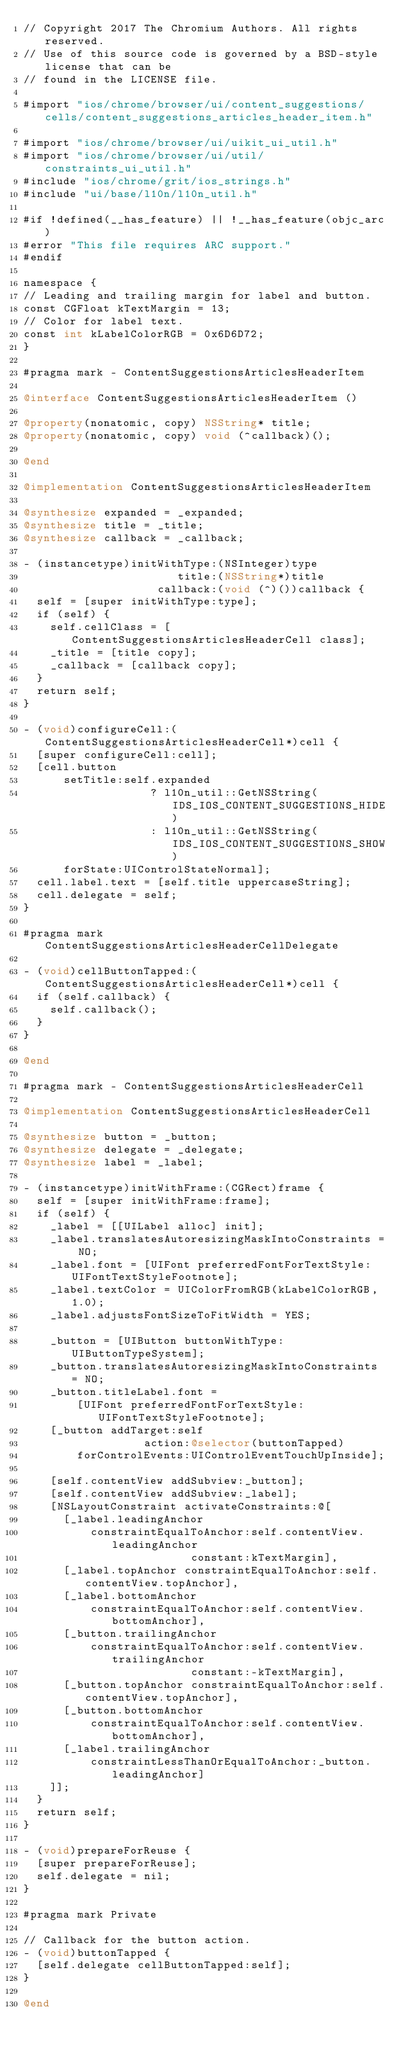Convert code to text. <code><loc_0><loc_0><loc_500><loc_500><_ObjectiveC_>// Copyright 2017 The Chromium Authors. All rights reserved.
// Use of this source code is governed by a BSD-style license that can be
// found in the LICENSE file.

#import "ios/chrome/browser/ui/content_suggestions/cells/content_suggestions_articles_header_item.h"

#import "ios/chrome/browser/ui/uikit_ui_util.h"
#import "ios/chrome/browser/ui/util/constraints_ui_util.h"
#include "ios/chrome/grit/ios_strings.h"
#include "ui/base/l10n/l10n_util.h"

#if !defined(__has_feature) || !__has_feature(objc_arc)
#error "This file requires ARC support."
#endif

namespace {
// Leading and trailing margin for label and button.
const CGFloat kTextMargin = 13;
// Color for label text.
const int kLabelColorRGB = 0x6D6D72;
}

#pragma mark - ContentSuggestionsArticlesHeaderItem

@interface ContentSuggestionsArticlesHeaderItem ()

@property(nonatomic, copy) NSString* title;
@property(nonatomic, copy) void (^callback)();

@end

@implementation ContentSuggestionsArticlesHeaderItem

@synthesize expanded = _expanded;
@synthesize title = _title;
@synthesize callback = _callback;

- (instancetype)initWithType:(NSInteger)type
                       title:(NSString*)title
                    callback:(void (^)())callback {
  self = [super initWithType:type];
  if (self) {
    self.cellClass = [ContentSuggestionsArticlesHeaderCell class];
    _title = [title copy];
    _callback = [callback copy];
  }
  return self;
}

- (void)configureCell:(ContentSuggestionsArticlesHeaderCell*)cell {
  [super configureCell:cell];
  [cell.button
      setTitle:self.expanded
                   ? l10n_util::GetNSString(IDS_IOS_CONTENT_SUGGESTIONS_HIDE)
                   : l10n_util::GetNSString(IDS_IOS_CONTENT_SUGGESTIONS_SHOW)
      forState:UIControlStateNormal];
  cell.label.text = [self.title uppercaseString];
  cell.delegate = self;
}

#pragma mark ContentSuggestionsArticlesHeaderCellDelegate

- (void)cellButtonTapped:(ContentSuggestionsArticlesHeaderCell*)cell {
  if (self.callback) {
    self.callback();
  }
}

@end

#pragma mark - ContentSuggestionsArticlesHeaderCell

@implementation ContentSuggestionsArticlesHeaderCell

@synthesize button = _button;
@synthesize delegate = _delegate;
@synthesize label = _label;

- (instancetype)initWithFrame:(CGRect)frame {
  self = [super initWithFrame:frame];
  if (self) {
    _label = [[UILabel alloc] init];
    _label.translatesAutoresizingMaskIntoConstraints = NO;
    _label.font = [UIFont preferredFontForTextStyle:UIFontTextStyleFootnote];
    _label.textColor = UIColorFromRGB(kLabelColorRGB, 1.0);
    _label.adjustsFontSizeToFitWidth = YES;

    _button = [UIButton buttonWithType:UIButtonTypeSystem];
    _button.translatesAutoresizingMaskIntoConstraints = NO;
    _button.titleLabel.font =
        [UIFont preferredFontForTextStyle:UIFontTextStyleFootnote];
    [_button addTarget:self
                  action:@selector(buttonTapped)
        forControlEvents:UIControlEventTouchUpInside];

    [self.contentView addSubview:_button];
    [self.contentView addSubview:_label];
    [NSLayoutConstraint activateConstraints:@[
      [_label.leadingAnchor
          constraintEqualToAnchor:self.contentView.leadingAnchor
                         constant:kTextMargin],
      [_label.topAnchor constraintEqualToAnchor:self.contentView.topAnchor],
      [_label.bottomAnchor
          constraintEqualToAnchor:self.contentView.bottomAnchor],
      [_button.trailingAnchor
          constraintEqualToAnchor:self.contentView.trailingAnchor
                         constant:-kTextMargin],
      [_button.topAnchor constraintEqualToAnchor:self.contentView.topAnchor],
      [_button.bottomAnchor
          constraintEqualToAnchor:self.contentView.bottomAnchor],
      [_label.trailingAnchor
          constraintLessThanOrEqualToAnchor:_button.leadingAnchor]
    ]];
  }
  return self;
}

- (void)prepareForReuse {
  [super prepareForReuse];
  self.delegate = nil;
}

#pragma mark Private

// Callback for the button action.
- (void)buttonTapped {
  [self.delegate cellButtonTapped:self];
}

@end
</code> 